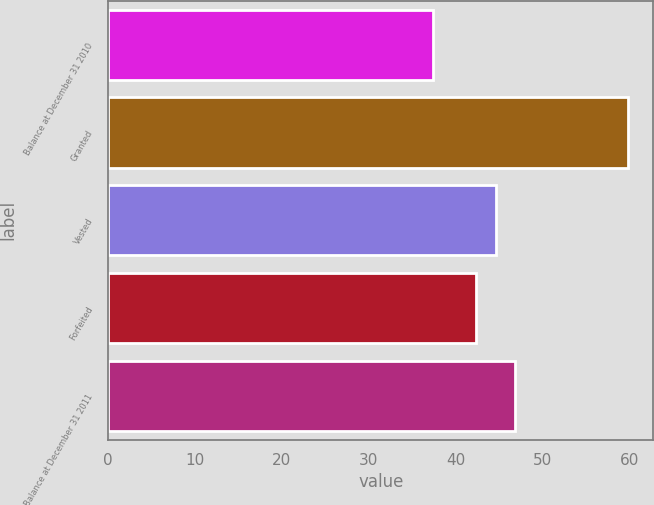<chart> <loc_0><loc_0><loc_500><loc_500><bar_chart><fcel>Balance at December 31 2010<fcel>Granted<fcel>Vested<fcel>Forfeited<fcel>Balance at December 31 2011<nl><fcel>37.43<fcel>59.8<fcel>44.63<fcel>42.39<fcel>46.87<nl></chart> 